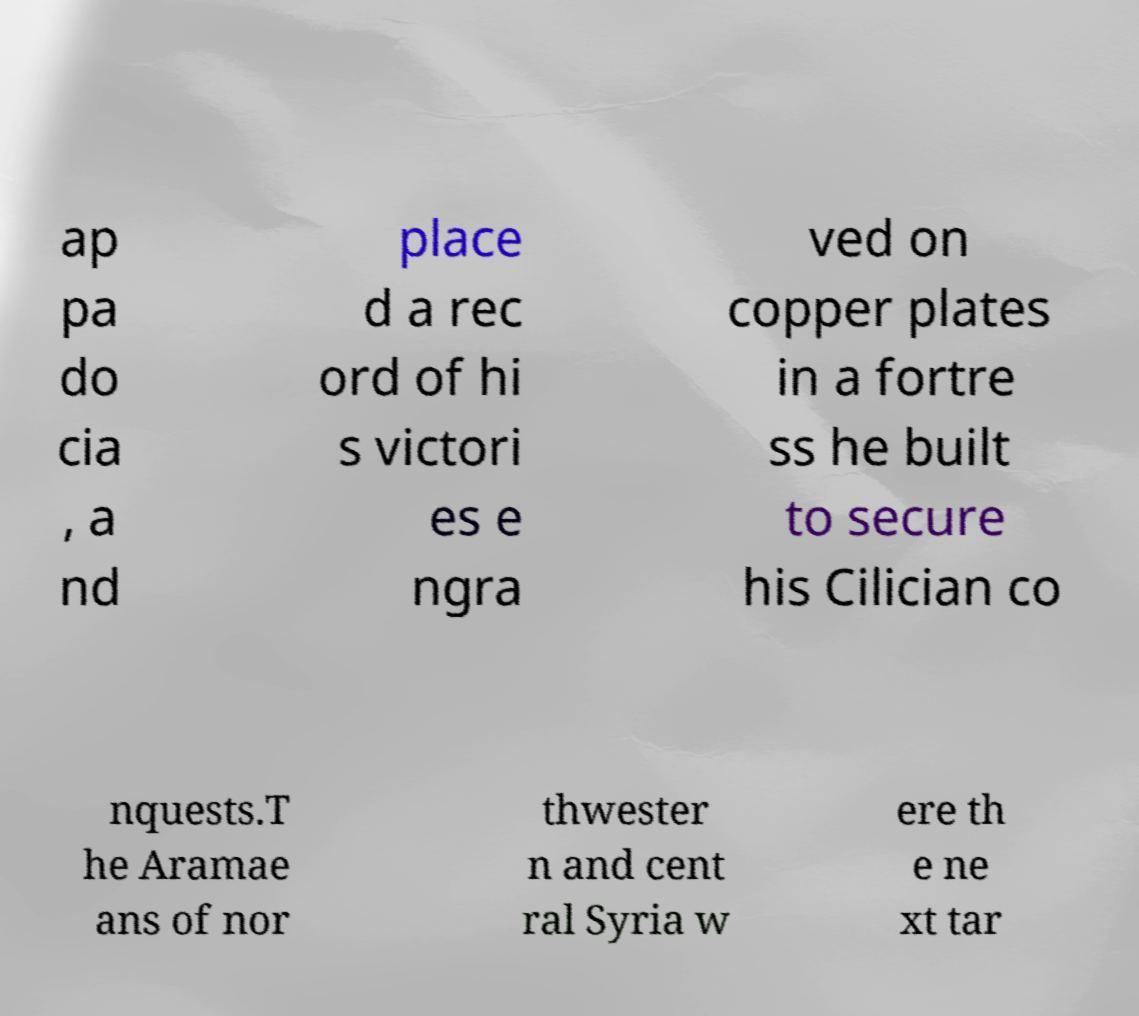Could you extract and type out the text from this image? ap pa do cia , a nd place d a rec ord of hi s victori es e ngra ved on copper plates in a fortre ss he built to secure his Cilician co nquests.T he Aramae ans of nor thwester n and cent ral Syria w ere th e ne xt tar 